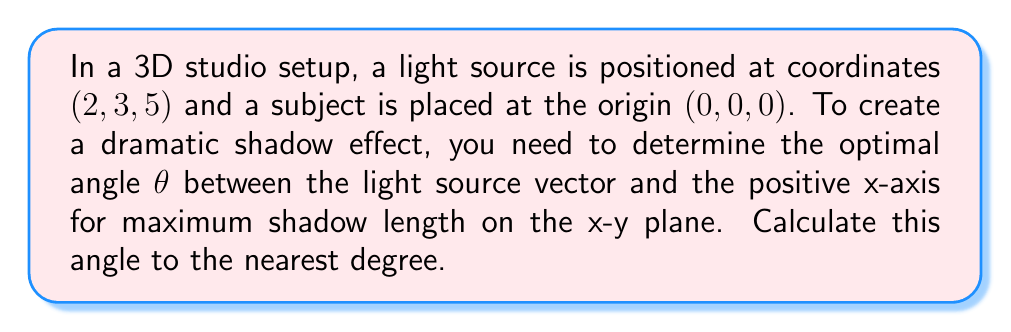Could you help me with this problem? To solve this problem, we'll follow these steps:

1) First, we need to find the vector from the origin to the light source:
   $\vec{v} = (2, 3, 5)$

2) We're interested in the angle between this vector and the positive x-axis in the x-y plane, so we can ignore the z-component:
   $\vec{v}_{xy} = (2, 3)$

3) The angle θ between this vector and the positive x-axis can be calculated using the arctangent function:
   $$θ = \arctan(\frac{y}{x})$$

4) Substituting our values:
   $$θ = \arctan(\frac{3}{2})$$

5) Calculate this value:
   $$θ ≈ 0.982 \text{ radians}$$

6) Convert to degrees:
   $$θ ≈ 0.982 \times \frac{180°}{\pi} ≈ 56.31°$$

7) Rounding to the nearest degree:
   $$θ ≈ 56°$$

This angle will create the longest shadow on the x-y plane, as it maximizes the distance between the light source projection and the subject on this plane.

[asy]
import geometry;

unitsize(30);
draw((-0.5,0)--(3,0),Arrow);
draw((0,-0.5)--(0,3),Arrow);
dot((2,3));
draw((0,0)--(2,3),Arrow);
draw(arc((0,0),0.7,0,56),Arrow);
label("x",(3,0),E);
label("y",(0,3),N);
label("Light source",(2,3),NE);
label("θ",(0.4,0.4));
[/asy]
Answer: 56° 